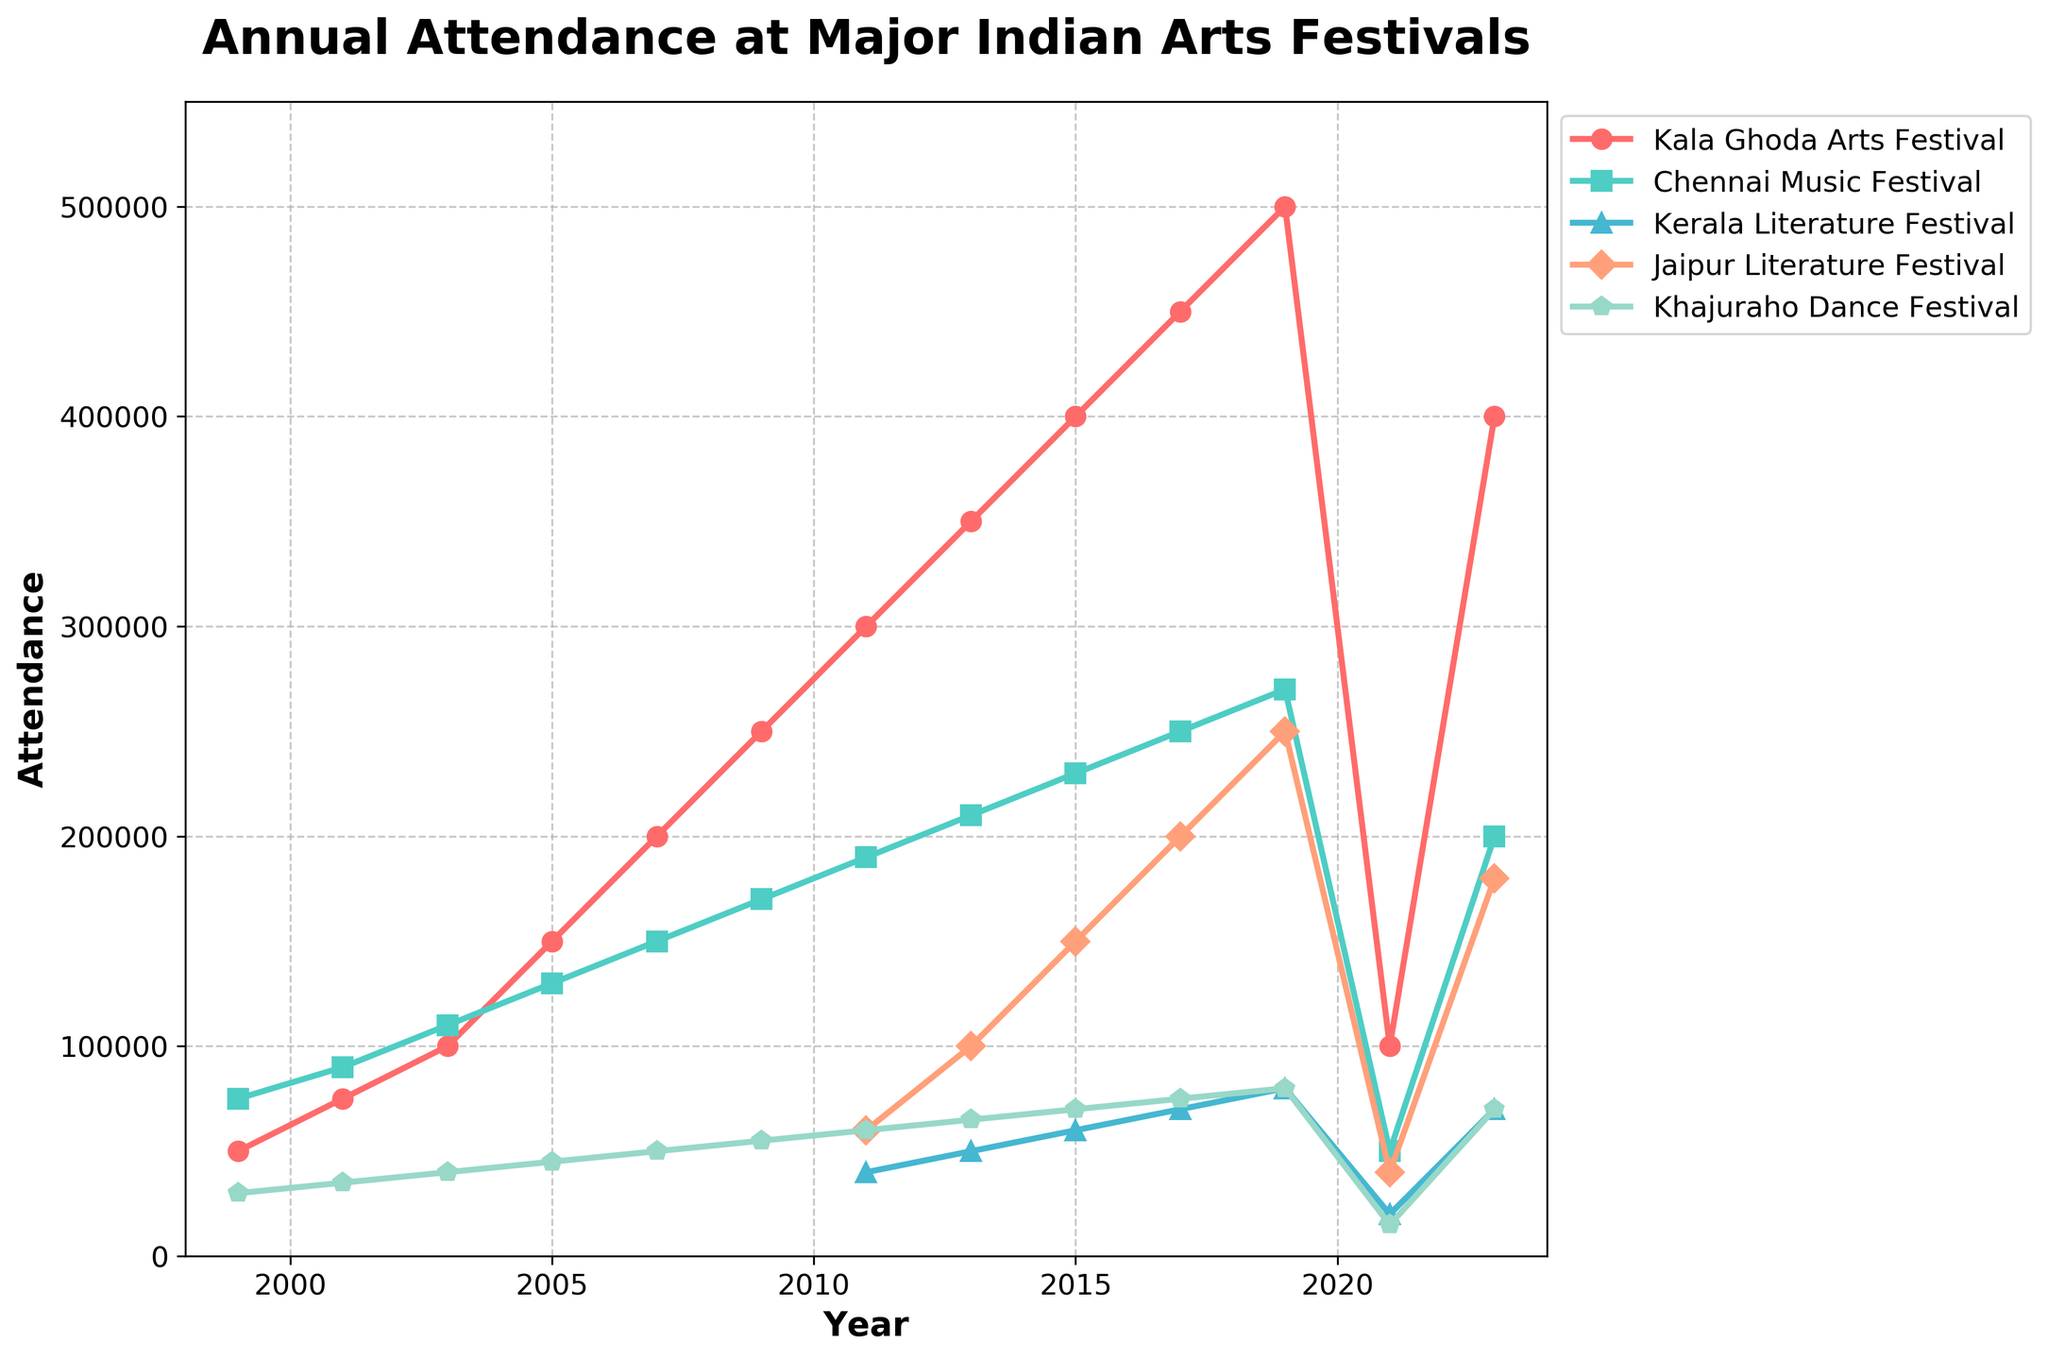1. What was the highest attendance for the Jaipur Literature Festival? By observing the maximum point for the Jaipur Literature Festival line, we can see it reaches 250,000 in 2019.
Answer: 250,000 2. In which year did the Kala Ghoda Arts Festival attendances surpass 300,000 for the first time? The Kala Ghoda Arts Festival line surpasses 300,000 for the first time in 2011.
Answer: 2011 3. Compare the trends between the Chennai Music Festival and Kerala Literature Festival between 2011 and 2021. The Chennai Music Festival's attendance shows a peak in 2019 and then a sharp decline in 2021. Meanwhile, the Kerala Literature Festival shows a gradual increase to 2019 and then also sees a steep decline in 2021.
Answer: Both increased until 2019 and then declined in 2021 4. Identify the festival with the smallest attendance drop in 2021. Reading the smallest drop in the year 2021, Kerala Literature Festival dropped to about 20,000 from 80,000 in 2019, which is a 60,000 drop. Kala Ghoda Festival is a larger drop from 500,000 to 100,000. Chennai Music Festival from 270,000 to 50,000. Jaipur Literature Festival was 250,000 to 40,000. Khajuraho Dance Festival was a minor drop from 80000 to 15000.
Answer: Kerala Literature Festival 5. In 2013, what was the difference in attendance between the Kerala Literature Festival and the Khajuraho Dance Festival? From the chart, 2013 shows 65,000 attendants for Khajuraho and 50,000 for Kerala. So the difference is 65,000 - 50,000 = 15,000.
Answer: 15,000 6. How many festivals reached their peak attendance in 2019? Observing each line, all maximum points for Chennai Music Festival, Kerala Literature Festival, Jaipur Literature Festival and Khajuraho Dance Festival happened in 2019.
Answer: Four 7. What color represents Kerala Literature Festival, and how did its attendance change from the first year it appeared to 2019? Kerala Literature Festival is represented by the blue line. It starts at 40,000 in 2011 and increases to 80,000 in 2019 before dropping in subsequent years.
Answer: Blue, increased initially 8. What was the trend for the Khajuraho Dance Festival from 1999 to 2021? The Khajuraho Dance Festival shows a steady increase from 30,000 in 1999 to a peak of 80,000 by 2019, followed by a sharp drop in 2021.
Answer: Increased, peak, then dropped 9. What was the lowest attendance recorded for the Chennai Music Festival, and in which year did this occur? The lowest attendance for Chennai Music Festival was recorded in 2021 with attendance of 50,000.
Answer: 2021 10. Calculate the average attendance for the Jaipur Literature Festival between 2011 and 2017. From the chart, Jaipur Literature Festival had 60,000 in 2011, 100,000 in 2013, 150,000 in 2015, and 200,000 in 2017. The average is (60,000 + 100,000 + 150,000 + 200,000)/4 = 127,500.
Answer: 127,500 